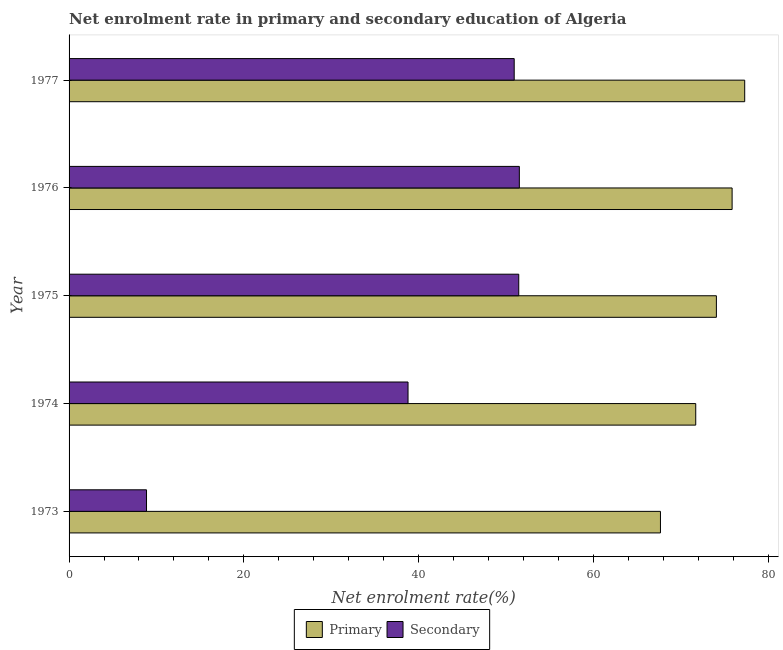How many different coloured bars are there?
Offer a terse response. 2. How many groups of bars are there?
Your response must be concise. 5. Are the number of bars per tick equal to the number of legend labels?
Provide a short and direct response. Yes. How many bars are there on the 5th tick from the bottom?
Ensure brevity in your answer.  2. What is the label of the 4th group of bars from the top?
Your answer should be compact. 1974. In how many cases, is the number of bars for a given year not equal to the number of legend labels?
Your response must be concise. 0. What is the enrollment rate in primary education in 1976?
Your response must be concise. 75.87. Across all years, what is the maximum enrollment rate in primary education?
Your answer should be compact. 77.32. Across all years, what is the minimum enrollment rate in secondary education?
Your answer should be compact. 8.86. In which year was the enrollment rate in primary education maximum?
Your answer should be compact. 1977. In which year was the enrollment rate in primary education minimum?
Give a very brief answer. 1973. What is the total enrollment rate in secondary education in the graph?
Your answer should be compact. 201.58. What is the difference between the enrollment rate in secondary education in 1975 and that in 1977?
Your response must be concise. 0.52. What is the difference between the enrollment rate in secondary education in 1974 and the enrollment rate in primary education in 1977?
Your answer should be compact. -38.53. What is the average enrollment rate in primary education per year?
Give a very brief answer. 73.33. In the year 1973, what is the difference between the enrollment rate in secondary education and enrollment rate in primary education?
Ensure brevity in your answer.  -58.81. In how many years, is the enrollment rate in primary education greater than 60 %?
Ensure brevity in your answer.  5. Is the difference between the enrollment rate in primary education in 1973 and 1974 greater than the difference between the enrollment rate in secondary education in 1973 and 1974?
Offer a very short reply. Yes. What is the difference between the highest and the second highest enrollment rate in secondary education?
Your answer should be compact. 0.07. What is the difference between the highest and the lowest enrollment rate in secondary education?
Provide a succinct answer. 42.66. What does the 2nd bar from the top in 1977 represents?
Give a very brief answer. Primary. What does the 2nd bar from the bottom in 1975 represents?
Your response must be concise. Secondary. How many bars are there?
Give a very brief answer. 10. Are all the bars in the graph horizontal?
Give a very brief answer. Yes. How many years are there in the graph?
Provide a succinct answer. 5. Are the values on the major ticks of X-axis written in scientific E-notation?
Provide a short and direct response. No. Does the graph contain grids?
Give a very brief answer. No. How many legend labels are there?
Your response must be concise. 2. How are the legend labels stacked?
Ensure brevity in your answer.  Horizontal. What is the title of the graph?
Your answer should be very brief. Net enrolment rate in primary and secondary education of Algeria. Does "Enforce a contract" appear as one of the legend labels in the graph?
Offer a very short reply. No. What is the label or title of the X-axis?
Ensure brevity in your answer.  Net enrolment rate(%). What is the label or title of the Y-axis?
Provide a succinct answer. Year. What is the Net enrolment rate(%) of Primary in 1973?
Give a very brief answer. 67.68. What is the Net enrolment rate(%) in Secondary in 1973?
Make the answer very short. 8.86. What is the Net enrolment rate(%) in Primary in 1974?
Give a very brief answer. 71.71. What is the Net enrolment rate(%) of Secondary in 1974?
Give a very brief answer. 38.79. What is the Net enrolment rate(%) in Primary in 1975?
Provide a short and direct response. 74.08. What is the Net enrolment rate(%) of Secondary in 1975?
Make the answer very short. 51.46. What is the Net enrolment rate(%) of Primary in 1976?
Your response must be concise. 75.87. What is the Net enrolment rate(%) of Secondary in 1976?
Provide a succinct answer. 51.53. What is the Net enrolment rate(%) of Primary in 1977?
Offer a very short reply. 77.32. What is the Net enrolment rate(%) in Secondary in 1977?
Offer a terse response. 50.94. Across all years, what is the maximum Net enrolment rate(%) in Primary?
Ensure brevity in your answer.  77.32. Across all years, what is the maximum Net enrolment rate(%) of Secondary?
Keep it short and to the point. 51.53. Across all years, what is the minimum Net enrolment rate(%) in Primary?
Your response must be concise. 67.68. Across all years, what is the minimum Net enrolment rate(%) in Secondary?
Provide a short and direct response. 8.86. What is the total Net enrolment rate(%) in Primary in the graph?
Your answer should be very brief. 366.65. What is the total Net enrolment rate(%) of Secondary in the graph?
Provide a succinct answer. 201.58. What is the difference between the Net enrolment rate(%) in Primary in 1973 and that in 1974?
Offer a very short reply. -4.04. What is the difference between the Net enrolment rate(%) of Secondary in 1973 and that in 1974?
Ensure brevity in your answer.  -29.93. What is the difference between the Net enrolment rate(%) in Primary in 1973 and that in 1975?
Make the answer very short. -6.4. What is the difference between the Net enrolment rate(%) in Secondary in 1973 and that in 1975?
Give a very brief answer. -42.6. What is the difference between the Net enrolment rate(%) in Primary in 1973 and that in 1976?
Ensure brevity in your answer.  -8.2. What is the difference between the Net enrolment rate(%) of Secondary in 1973 and that in 1976?
Provide a succinct answer. -42.66. What is the difference between the Net enrolment rate(%) of Primary in 1973 and that in 1977?
Offer a very short reply. -9.64. What is the difference between the Net enrolment rate(%) of Secondary in 1973 and that in 1977?
Your answer should be compact. -42.07. What is the difference between the Net enrolment rate(%) of Primary in 1974 and that in 1975?
Your answer should be very brief. -2.36. What is the difference between the Net enrolment rate(%) in Secondary in 1974 and that in 1975?
Ensure brevity in your answer.  -12.67. What is the difference between the Net enrolment rate(%) of Primary in 1974 and that in 1976?
Offer a terse response. -4.16. What is the difference between the Net enrolment rate(%) of Secondary in 1974 and that in 1976?
Keep it short and to the point. -12.74. What is the difference between the Net enrolment rate(%) in Primary in 1974 and that in 1977?
Keep it short and to the point. -5.61. What is the difference between the Net enrolment rate(%) of Secondary in 1974 and that in 1977?
Provide a succinct answer. -12.15. What is the difference between the Net enrolment rate(%) of Primary in 1975 and that in 1976?
Your response must be concise. -1.8. What is the difference between the Net enrolment rate(%) of Secondary in 1975 and that in 1976?
Ensure brevity in your answer.  -0.07. What is the difference between the Net enrolment rate(%) of Primary in 1975 and that in 1977?
Your answer should be compact. -3.24. What is the difference between the Net enrolment rate(%) of Secondary in 1975 and that in 1977?
Offer a terse response. 0.52. What is the difference between the Net enrolment rate(%) in Primary in 1976 and that in 1977?
Offer a terse response. -1.44. What is the difference between the Net enrolment rate(%) in Secondary in 1976 and that in 1977?
Provide a succinct answer. 0.59. What is the difference between the Net enrolment rate(%) in Primary in 1973 and the Net enrolment rate(%) in Secondary in 1974?
Keep it short and to the point. 28.89. What is the difference between the Net enrolment rate(%) in Primary in 1973 and the Net enrolment rate(%) in Secondary in 1975?
Keep it short and to the point. 16.22. What is the difference between the Net enrolment rate(%) of Primary in 1973 and the Net enrolment rate(%) of Secondary in 1976?
Offer a terse response. 16.15. What is the difference between the Net enrolment rate(%) of Primary in 1973 and the Net enrolment rate(%) of Secondary in 1977?
Ensure brevity in your answer.  16.74. What is the difference between the Net enrolment rate(%) of Primary in 1974 and the Net enrolment rate(%) of Secondary in 1975?
Keep it short and to the point. 20.25. What is the difference between the Net enrolment rate(%) of Primary in 1974 and the Net enrolment rate(%) of Secondary in 1976?
Your response must be concise. 20.18. What is the difference between the Net enrolment rate(%) in Primary in 1974 and the Net enrolment rate(%) in Secondary in 1977?
Provide a succinct answer. 20.77. What is the difference between the Net enrolment rate(%) of Primary in 1975 and the Net enrolment rate(%) of Secondary in 1976?
Provide a succinct answer. 22.55. What is the difference between the Net enrolment rate(%) of Primary in 1975 and the Net enrolment rate(%) of Secondary in 1977?
Give a very brief answer. 23.14. What is the difference between the Net enrolment rate(%) in Primary in 1976 and the Net enrolment rate(%) in Secondary in 1977?
Offer a very short reply. 24.94. What is the average Net enrolment rate(%) of Primary per year?
Make the answer very short. 73.33. What is the average Net enrolment rate(%) of Secondary per year?
Your answer should be compact. 40.32. In the year 1973, what is the difference between the Net enrolment rate(%) in Primary and Net enrolment rate(%) in Secondary?
Make the answer very short. 58.81. In the year 1974, what is the difference between the Net enrolment rate(%) of Primary and Net enrolment rate(%) of Secondary?
Make the answer very short. 32.92. In the year 1975, what is the difference between the Net enrolment rate(%) of Primary and Net enrolment rate(%) of Secondary?
Make the answer very short. 22.62. In the year 1976, what is the difference between the Net enrolment rate(%) in Primary and Net enrolment rate(%) in Secondary?
Offer a terse response. 24.35. In the year 1977, what is the difference between the Net enrolment rate(%) in Primary and Net enrolment rate(%) in Secondary?
Ensure brevity in your answer.  26.38. What is the ratio of the Net enrolment rate(%) of Primary in 1973 to that in 1974?
Ensure brevity in your answer.  0.94. What is the ratio of the Net enrolment rate(%) in Secondary in 1973 to that in 1974?
Ensure brevity in your answer.  0.23. What is the ratio of the Net enrolment rate(%) of Primary in 1973 to that in 1975?
Give a very brief answer. 0.91. What is the ratio of the Net enrolment rate(%) of Secondary in 1973 to that in 1975?
Ensure brevity in your answer.  0.17. What is the ratio of the Net enrolment rate(%) of Primary in 1973 to that in 1976?
Give a very brief answer. 0.89. What is the ratio of the Net enrolment rate(%) in Secondary in 1973 to that in 1976?
Offer a terse response. 0.17. What is the ratio of the Net enrolment rate(%) of Primary in 1973 to that in 1977?
Your answer should be compact. 0.88. What is the ratio of the Net enrolment rate(%) in Secondary in 1973 to that in 1977?
Give a very brief answer. 0.17. What is the ratio of the Net enrolment rate(%) in Primary in 1974 to that in 1975?
Your answer should be very brief. 0.97. What is the ratio of the Net enrolment rate(%) in Secondary in 1974 to that in 1975?
Your response must be concise. 0.75. What is the ratio of the Net enrolment rate(%) of Primary in 1974 to that in 1976?
Your answer should be compact. 0.95. What is the ratio of the Net enrolment rate(%) of Secondary in 1974 to that in 1976?
Offer a terse response. 0.75. What is the ratio of the Net enrolment rate(%) of Primary in 1974 to that in 1977?
Your answer should be very brief. 0.93. What is the ratio of the Net enrolment rate(%) in Secondary in 1974 to that in 1977?
Provide a short and direct response. 0.76. What is the ratio of the Net enrolment rate(%) in Primary in 1975 to that in 1976?
Your response must be concise. 0.98. What is the ratio of the Net enrolment rate(%) in Primary in 1975 to that in 1977?
Your response must be concise. 0.96. What is the ratio of the Net enrolment rate(%) of Secondary in 1975 to that in 1977?
Ensure brevity in your answer.  1.01. What is the ratio of the Net enrolment rate(%) of Primary in 1976 to that in 1977?
Make the answer very short. 0.98. What is the ratio of the Net enrolment rate(%) of Secondary in 1976 to that in 1977?
Your answer should be compact. 1.01. What is the difference between the highest and the second highest Net enrolment rate(%) of Primary?
Provide a succinct answer. 1.44. What is the difference between the highest and the second highest Net enrolment rate(%) in Secondary?
Ensure brevity in your answer.  0.07. What is the difference between the highest and the lowest Net enrolment rate(%) of Primary?
Make the answer very short. 9.64. What is the difference between the highest and the lowest Net enrolment rate(%) in Secondary?
Your answer should be compact. 42.66. 